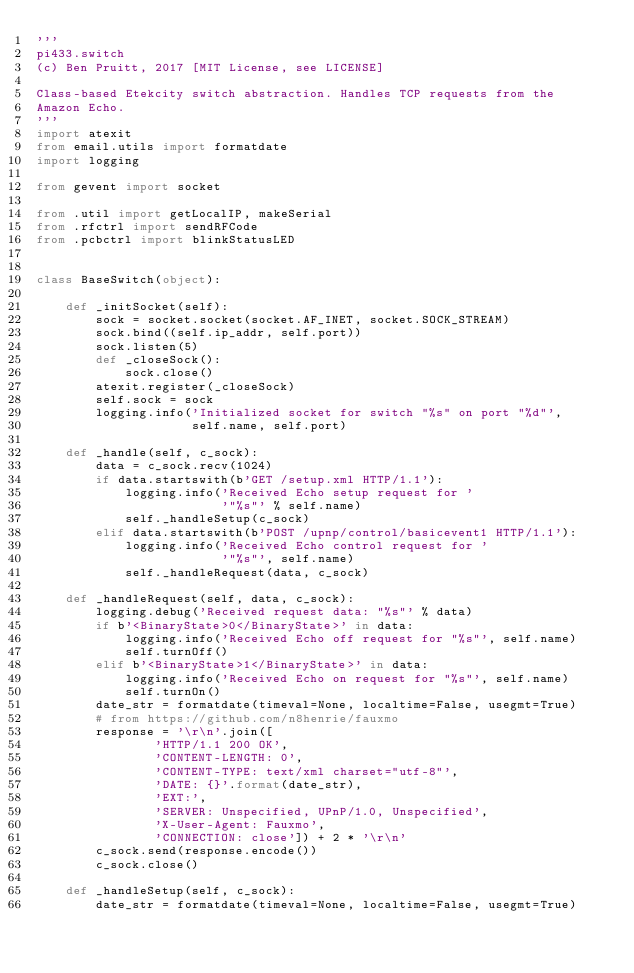<code> <loc_0><loc_0><loc_500><loc_500><_Python_>'''
pi433.switch
(c) Ben Pruitt, 2017 [MIT License, see LICENSE]

Class-based Etekcity switch abstraction. Handles TCP requests from the
Amazon Echo.
'''
import atexit
from email.utils import formatdate
import logging

from gevent import socket

from .util import getLocalIP, makeSerial
from .rfctrl import sendRFCode
from .pcbctrl import blinkStatusLED


class BaseSwitch(object):

    def _initSocket(self):
        sock = socket.socket(socket.AF_INET, socket.SOCK_STREAM)
        sock.bind((self.ip_addr, self.port))
        sock.listen(5)
        def _closeSock():
            sock.close()
        atexit.register(_closeSock)
        self.sock = sock
        logging.info('Initialized socket for switch "%s" on port "%d"',
                     self.name, self.port)

    def _handle(self, c_sock):
        data = c_sock.recv(1024)
        if data.startswith(b'GET /setup.xml HTTP/1.1'):
            logging.info('Received Echo setup request for '
                         '"%s"' % self.name)
            self._handleSetup(c_sock)
        elif data.startswith(b'POST /upnp/control/basicevent1 HTTP/1.1'):
            logging.info('Received Echo control request for '
                         '"%s"', self.name)
            self._handleRequest(data, c_sock)

    def _handleRequest(self, data, c_sock):
        logging.debug('Received request data: "%s"' % data)
        if b'<BinaryState>0</BinaryState>' in data:
            logging.info('Received Echo off request for "%s"', self.name)
            self.turnOff()
        elif b'<BinaryState>1</BinaryState>' in data:
            logging.info('Received Echo on request for "%s"', self.name)
            self.turnOn()
        date_str = formatdate(timeval=None, localtime=False, usegmt=True)
        # from https://github.com/n8henrie/fauxmo
        response = '\r\n'.join([
                'HTTP/1.1 200 OK',
                'CONTENT-LENGTH: 0',
                'CONTENT-TYPE: text/xml charset="utf-8"',
                'DATE: {}'.format(date_str),
                'EXT:',
                'SERVER: Unspecified, UPnP/1.0, Unspecified',
                'X-User-Agent: Fauxmo',
                'CONNECTION: close']) + 2 * '\r\n'
        c_sock.send(response.encode())
        c_sock.close()

    def _handleSetup(self, c_sock):
        date_str = formatdate(timeval=None, localtime=False, usegmt=True)</code> 